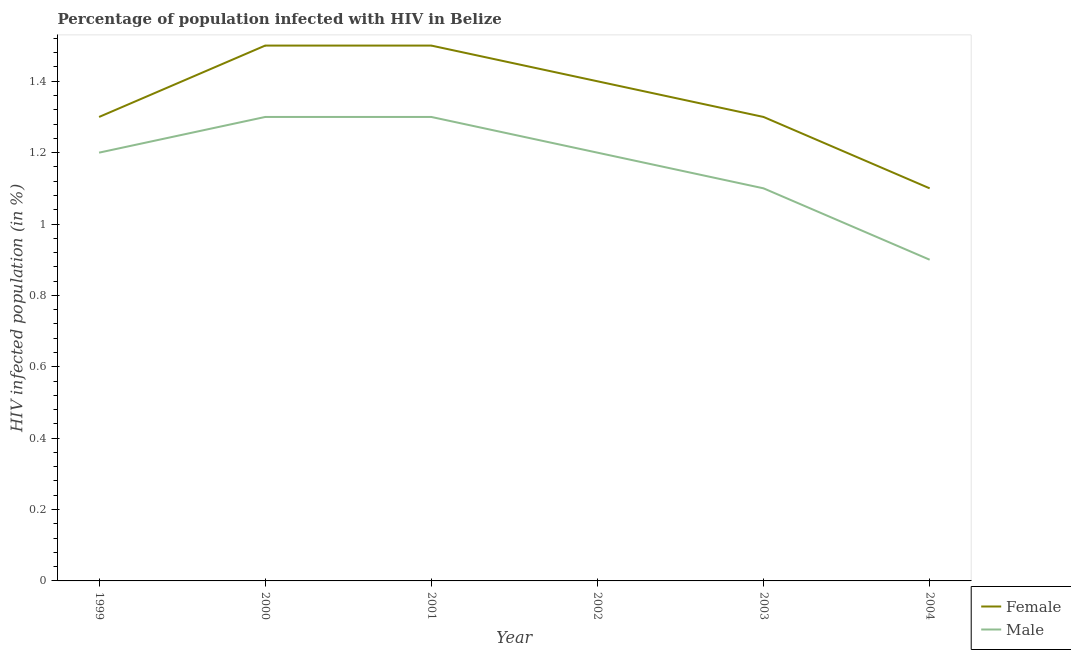Is the number of lines equal to the number of legend labels?
Provide a short and direct response. Yes. What is the percentage of males who are infected with hiv in 2001?
Ensure brevity in your answer.  1.3. Across all years, what is the minimum percentage of females who are infected with hiv?
Offer a terse response. 1.1. In which year was the percentage of males who are infected with hiv minimum?
Make the answer very short. 2004. What is the difference between the percentage of females who are infected with hiv in 2002 and that in 2004?
Ensure brevity in your answer.  0.3. What is the difference between the percentage of females who are infected with hiv in 1999 and the percentage of males who are infected with hiv in 2003?
Provide a succinct answer. 0.2. What is the average percentage of males who are infected with hiv per year?
Offer a terse response. 1.17. In the year 2004, what is the difference between the percentage of males who are infected with hiv and percentage of females who are infected with hiv?
Offer a terse response. -0.2. In how many years, is the percentage of males who are infected with hiv greater than 1.4800000000000002 %?
Give a very brief answer. 0. What is the ratio of the percentage of females who are infected with hiv in 2001 to that in 2002?
Offer a very short reply. 1.07. What is the difference between the highest and the lowest percentage of females who are infected with hiv?
Ensure brevity in your answer.  0.4. Is the percentage of males who are infected with hiv strictly greater than the percentage of females who are infected with hiv over the years?
Your response must be concise. No. Is the percentage of males who are infected with hiv strictly less than the percentage of females who are infected with hiv over the years?
Your answer should be very brief. Yes. How many years are there in the graph?
Your response must be concise. 6. Does the graph contain grids?
Provide a succinct answer. No. How many legend labels are there?
Give a very brief answer. 2. What is the title of the graph?
Offer a very short reply. Percentage of population infected with HIV in Belize. Does "Male labourers" appear as one of the legend labels in the graph?
Keep it short and to the point. No. What is the label or title of the X-axis?
Offer a very short reply. Year. What is the label or title of the Y-axis?
Provide a succinct answer. HIV infected population (in %). What is the HIV infected population (in %) of Female in 1999?
Give a very brief answer. 1.3. What is the HIV infected population (in %) of Female in 2000?
Your answer should be very brief. 1.5. What is the HIV infected population (in %) in Female in 2001?
Give a very brief answer. 1.5. What is the HIV infected population (in %) in Female in 2004?
Keep it short and to the point. 1.1. What is the HIV infected population (in %) in Male in 2004?
Your response must be concise. 0.9. Across all years, what is the maximum HIV infected population (in %) of Female?
Ensure brevity in your answer.  1.5. Across all years, what is the maximum HIV infected population (in %) of Male?
Give a very brief answer. 1.3. What is the total HIV infected population (in %) of Male in the graph?
Offer a very short reply. 7. What is the difference between the HIV infected population (in %) in Female in 1999 and that in 2001?
Make the answer very short. -0.2. What is the difference between the HIV infected population (in %) in Male in 1999 and that in 2001?
Give a very brief answer. -0.1. What is the difference between the HIV infected population (in %) in Female in 1999 and that in 2002?
Make the answer very short. -0.1. What is the difference between the HIV infected population (in %) of Female in 1999 and that in 2003?
Keep it short and to the point. 0. What is the difference between the HIV infected population (in %) in Male in 1999 and that in 2003?
Provide a short and direct response. 0.1. What is the difference between the HIV infected population (in %) of Female in 2000 and that in 2001?
Provide a short and direct response. 0. What is the difference between the HIV infected population (in %) in Male in 2000 and that in 2001?
Offer a terse response. 0. What is the difference between the HIV infected population (in %) of Male in 2000 and that in 2002?
Offer a very short reply. 0.1. What is the difference between the HIV infected population (in %) in Female in 2000 and that in 2004?
Offer a terse response. 0.4. What is the difference between the HIV infected population (in %) of Male in 2000 and that in 2004?
Offer a very short reply. 0.4. What is the difference between the HIV infected population (in %) in Female in 2001 and that in 2002?
Provide a short and direct response. 0.1. What is the difference between the HIV infected population (in %) in Female in 2001 and that in 2003?
Offer a very short reply. 0.2. What is the difference between the HIV infected population (in %) in Female in 2001 and that in 2004?
Make the answer very short. 0.4. What is the difference between the HIV infected population (in %) in Male in 2002 and that in 2003?
Make the answer very short. 0.1. What is the difference between the HIV infected population (in %) in Female in 2002 and that in 2004?
Offer a very short reply. 0.3. What is the difference between the HIV infected population (in %) in Female in 2003 and that in 2004?
Your answer should be compact. 0.2. What is the difference between the HIV infected population (in %) in Female in 2000 and the HIV infected population (in %) in Male in 2002?
Provide a short and direct response. 0.3. What is the difference between the HIV infected population (in %) of Female in 2000 and the HIV infected population (in %) of Male in 2003?
Your answer should be very brief. 0.4. What is the difference between the HIV infected population (in %) of Female in 2001 and the HIV infected population (in %) of Male in 2003?
Give a very brief answer. 0.4. What is the difference between the HIV infected population (in %) of Female in 2001 and the HIV infected population (in %) of Male in 2004?
Keep it short and to the point. 0.6. What is the average HIV infected population (in %) of Female per year?
Make the answer very short. 1.35. In the year 1999, what is the difference between the HIV infected population (in %) of Female and HIV infected population (in %) of Male?
Keep it short and to the point. 0.1. In the year 2001, what is the difference between the HIV infected population (in %) of Female and HIV infected population (in %) of Male?
Provide a succinct answer. 0.2. In the year 2003, what is the difference between the HIV infected population (in %) of Female and HIV infected population (in %) of Male?
Make the answer very short. 0.2. What is the ratio of the HIV infected population (in %) of Female in 1999 to that in 2000?
Keep it short and to the point. 0.87. What is the ratio of the HIV infected population (in %) in Male in 1999 to that in 2000?
Provide a short and direct response. 0.92. What is the ratio of the HIV infected population (in %) of Female in 1999 to that in 2001?
Offer a very short reply. 0.87. What is the ratio of the HIV infected population (in %) of Male in 1999 to that in 2003?
Your response must be concise. 1.09. What is the ratio of the HIV infected population (in %) in Female in 1999 to that in 2004?
Keep it short and to the point. 1.18. What is the ratio of the HIV infected population (in %) of Female in 2000 to that in 2001?
Keep it short and to the point. 1. What is the ratio of the HIV infected population (in %) of Female in 2000 to that in 2002?
Make the answer very short. 1.07. What is the ratio of the HIV infected population (in %) of Male in 2000 to that in 2002?
Offer a very short reply. 1.08. What is the ratio of the HIV infected population (in %) in Female in 2000 to that in 2003?
Give a very brief answer. 1.15. What is the ratio of the HIV infected population (in %) of Male in 2000 to that in 2003?
Your response must be concise. 1.18. What is the ratio of the HIV infected population (in %) in Female in 2000 to that in 2004?
Offer a very short reply. 1.36. What is the ratio of the HIV infected population (in %) in Male in 2000 to that in 2004?
Provide a short and direct response. 1.44. What is the ratio of the HIV infected population (in %) in Female in 2001 to that in 2002?
Make the answer very short. 1.07. What is the ratio of the HIV infected population (in %) of Female in 2001 to that in 2003?
Your response must be concise. 1.15. What is the ratio of the HIV infected population (in %) in Male in 2001 to that in 2003?
Your response must be concise. 1.18. What is the ratio of the HIV infected population (in %) in Female in 2001 to that in 2004?
Offer a terse response. 1.36. What is the ratio of the HIV infected population (in %) of Male in 2001 to that in 2004?
Your response must be concise. 1.44. What is the ratio of the HIV infected population (in %) of Female in 2002 to that in 2003?
Keep it short and to the point. 1.08. What is the ratio of the HIV infected population (in %) in Male in 2002 to that in 2003?
Provide a short and direct response. 1.09. What is the ratio of the HIV infected population (in %) in Female in 2002 to that in 2004?
Offer a terse response. 1.27. What is the ratio of the HIV infected population (in %) of Male in 2002 to that in 2004?
Your response must be concise. 1.33. What is the ratio of the HIV infected population (in %) of Female in 2003 to that in 2004?
Your response must be concise. 1.18. What is the ratio of the HIV infected population (in %) in Male in 2003 to that in 2004?
Your response must be concise. 1.22. What is the difference between the highest and the second highest HIV infected population (in %) of Female?
Offer a very short reply. 0. What is the difference between the highest and the second highest HIV infected population (in %) of Male?
Keep it short and to the point. 0. What is the difference between the highest and the lowest HIV infected population (in %) of Male?
Make the answer very short. 0.4. 